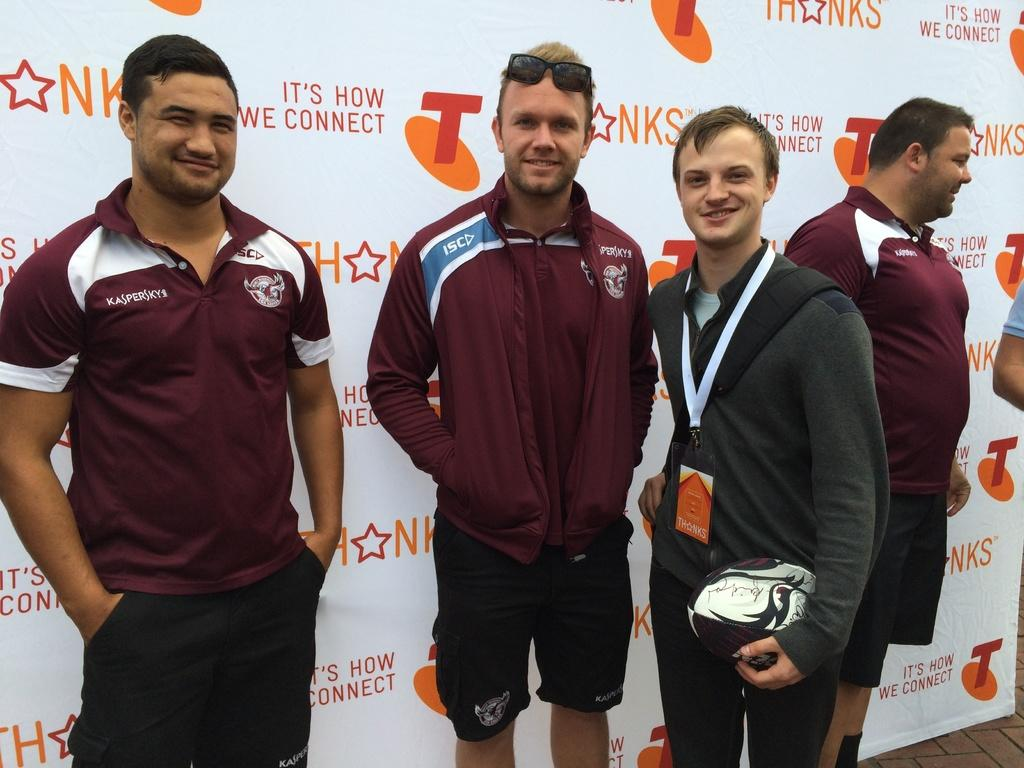<image>
Share a concise interpretation of the image provided. Men with maroon shirts that say Kasperskys pose in front of advertising background. 